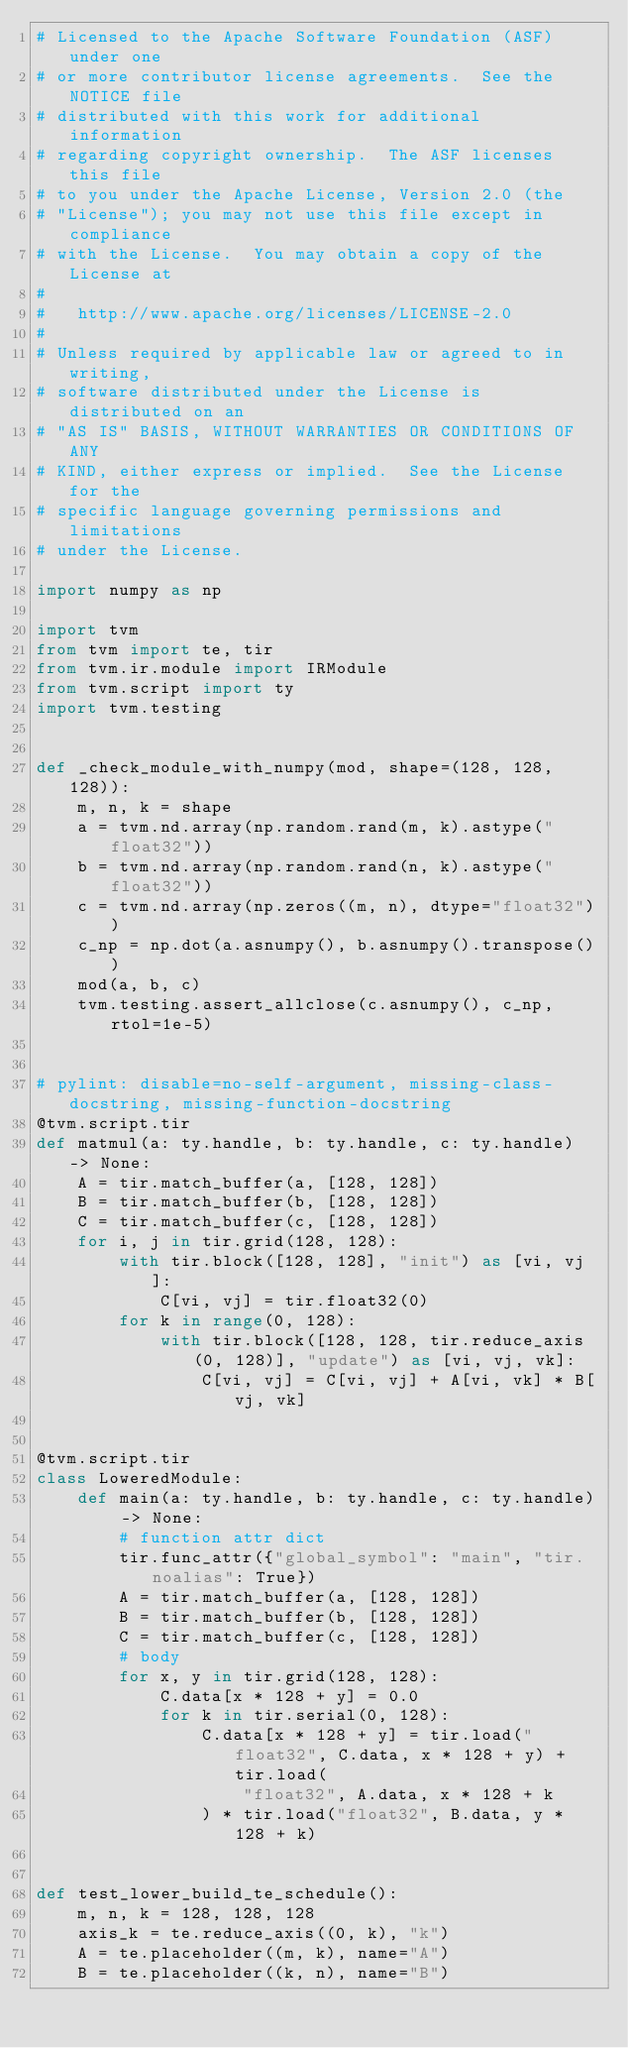Convert code to text. <code><loc_0><loc_0><loc_500><loc_500><_Python_># Licensed to the Apache Software Foundation (ASF) under one
# or more contributor license agreements.  See the NOTICE file
# distributed with this work for additional information
# regarding copyright ownership.  The ASF licenses this file
# to you under the Apache License, Version 2.0 (the
# "License"); you may not use this file except in compliance
# with the License.  You may obtain a copy of the License at
#
#   http://www.apache.org/licenses/LICENSE-2.0
#
# Unless required by applicable law or agreed to in writing,
# software distributed under the License is distributed on an
# "AS IS" BASIS, WITHOUT WARRANTIES OR CONDITIONS OF ANY
# KIND, either express or implied.  See the License for the
# specific language governing permissions and limitations
# under the License.

import numpy as np

import tvm
from tvm import te, tir
from tvm.ir.module import IRModule
from tvm.script import ty
import tvm.testing


def _check_module_with_numpy(mod, shape=(128, 128, 128)):
    m, n, k = shape
    a = tvm.nd.array(np.random.rand(m, k).astype("float32"))
    b = tvm.nd.array(np.random.rand(n, k).astype("float32"))
    c = tvm.nd.array(np.zeros((m, n), dtype="float32"))
    c_np = np.dot(a.asnumpy(), b.asnumpy().transpose())
    mod(a, b, c)
    tvm.testing.assert_allclose(c.asnumpy(), c_np, rtol=1e-5)


# pylint: disable=no-self-argument, missing-class-docstring, missing-function-docstring
@tvm.script.tir
def matmul(a: ty.handle, b: ty.handle, c: ty.handle) -> None:
    A = tir.match_buffer(a, [128, 128])
    B = tir.match_buffer(b, [128, 128])
    C = tir.match_buffer(c, [128, 128])
    for i, j in tir.grid(128, 128):
        with tir.block([128, 128], "init") as [vi, vj]:
            C[vi, vj] = tir.float32(0)
        for k in range(0, 128):
            with tir.block([128, 128, tir.reduce_axis(0, 128)], "update") as [vi, vj, vk]:
                C[vi, vj] = C[vi, vj] + A[vi, vk] * B[vj, vk]


@tvm.script.tir
class LoweredModule:
    def main(a: ty.handle, b: ty.handle, c: ty.handle) -> None:
        # function attr dict
        tir.func_attr({"global_symbol": "main", "tir.noalias": True})
        A = tir.match_buffer(a, [128, 128])
        B = tir.match_buffer(b, [128, 128])
        C = tir.match_buffer(c, [128, 128])
        # body
        for x, y in tir.grid(128, 128):
            C.data[x * 128 + y] = 0.0
            for k in tir.serial(0, 128):
                C.data[x * 128 + y] = tir.load("float32", C.data, x * 128 + y) + tir.load(
                    "float32", A.data, x * 128 + k
                ) * tir.load("float32", B.data, y * 128 + k)


def test_lower_build_te_schedule():
    m, n, k = 128, 128, 128
    axis_k = te.reduce_axis((0, k), "k")
    A = te.placeholder((m, k), name="A")
    B = te.placeholder((k, n), name="B")</code> 